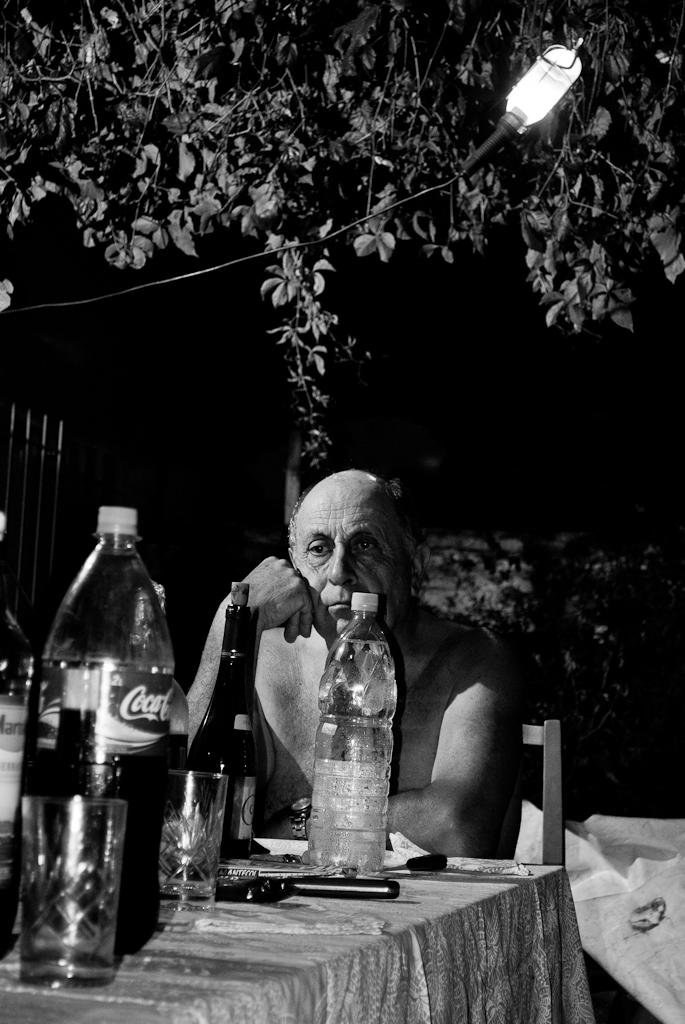<image>
Share a concise interpretation of the image provided. An elderly man who looks bored, is sitting at a table with glass cups, beer bottles, and Coca Cola bottles on it, outside. 